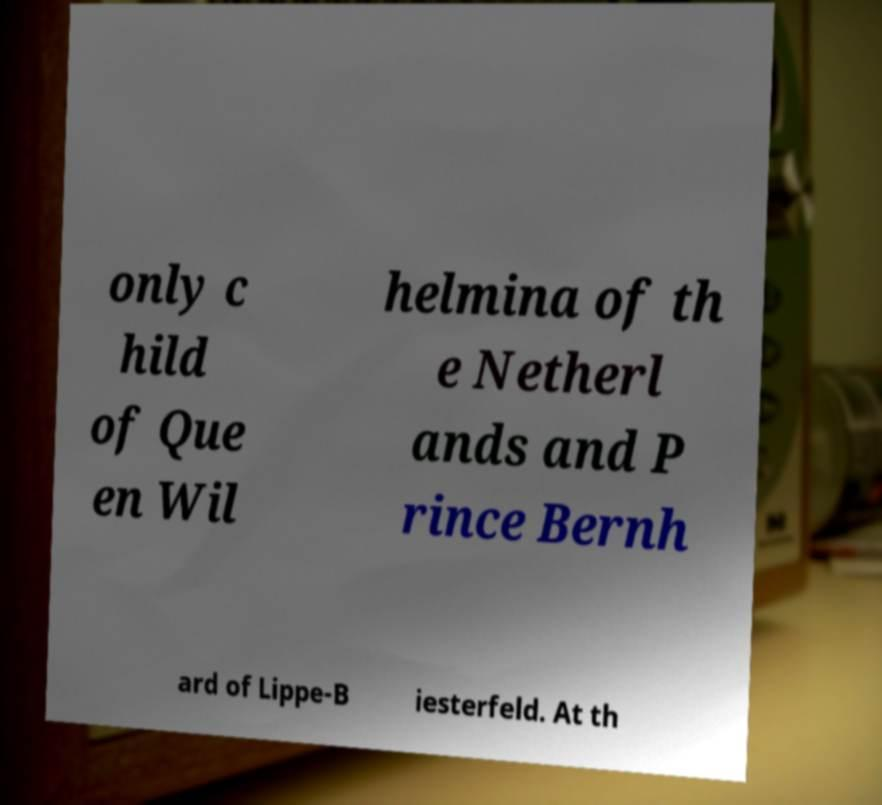Can you read and provide the text displayed in the image?This photo seems to have some interesting text. Can you extract and type it out for me? only c hild of Que en Wil helmina of th e Netherl ands and P rince Bernh ard of Lippe-B iesterfeld. At th 